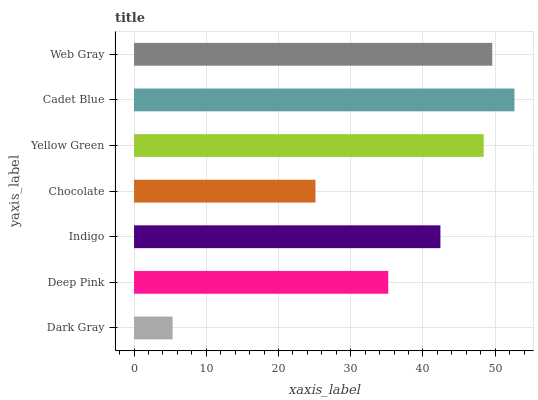Is Dark Gray the minimum?
Answer yes or no. Yes. Is Cadet Blue the maximum?
Answer yes or no. Yes. Is Deep Pink the minimum?
Answer yes or no. No. Is Deep Pink the maximum?
Answer yes or no. No. Is Deep Pink greater than Dark Gray?
Answer yes or no. Yes. Is Dark Gray less than Deep Pink?
Answer yes or no. Yes. Is Dark Gray greater than Deep Pink?
Answer yes or no. No. Is Deep Pink less than Dark Gray?
Answer yes or no. No. Is Indigo the high median?
Answer yes or no. Yes. Is Indigo the low median?
Answer yes or no. Yes. Is Chocolate the high median?
Answer yes or no. No. Is Chocolate the low median?
Answer yes or no. No. 